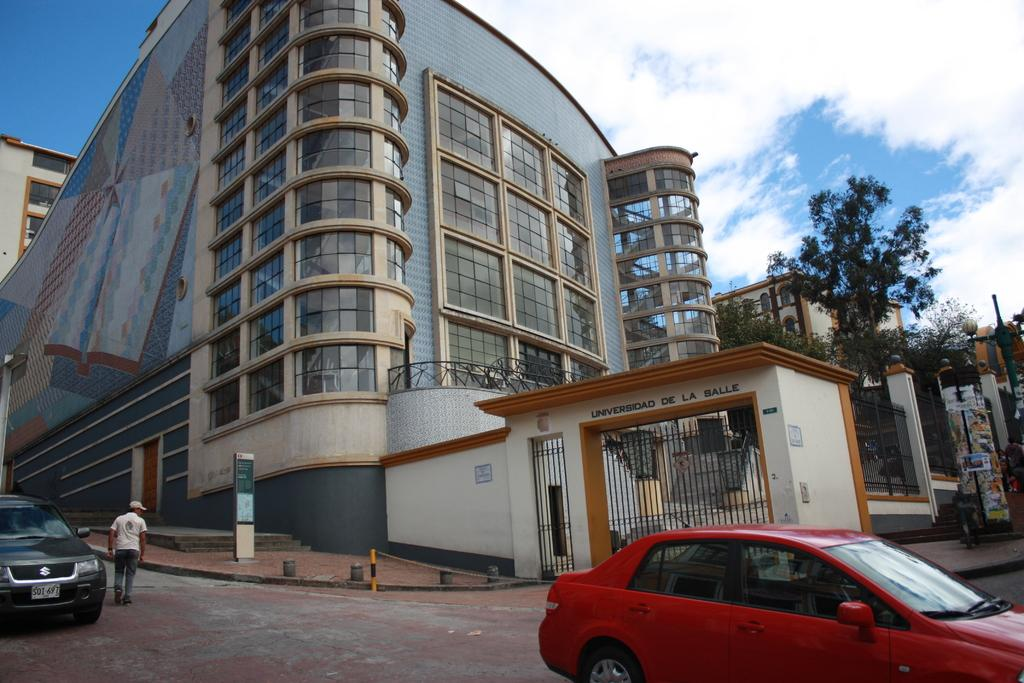What type of vehicle is on the right side of the image? There is a red car on the right side of the image. What is the car doing in the image? The car is moving on the road. What structure is located in the middle of the image? There is a big building in the middle of the image. What is the condition of the sky in the image? The sky is cloudy in the image. Where is the beggar standing in the image? There is no beggar present in the image. What type of lock is used to secure the car in the image? There is no lock visible on the car in the image. 